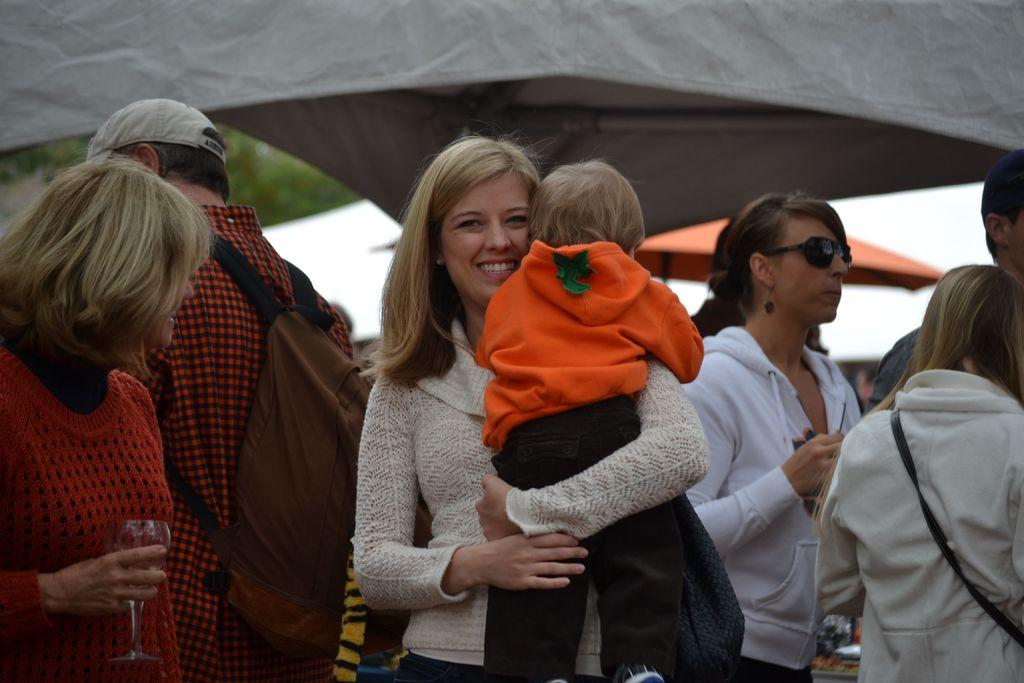What is the main subject of the image? The main subject of the image is a group of people standing. Can you describe any specific features or objects in the image? Yes, there is a tent in the image. What is the woman in the image doing? The woman is holding a boy and smiling. What is the man in the image wearing? The man is wearing a cap, shirt, and a bag. What type of bead is the man wearing around his throat in the image? There is no bead visible around the man's throat in the image. What is the man doing to the earth in the image? There is no indication in the image that the man is doing anything to the earth. 